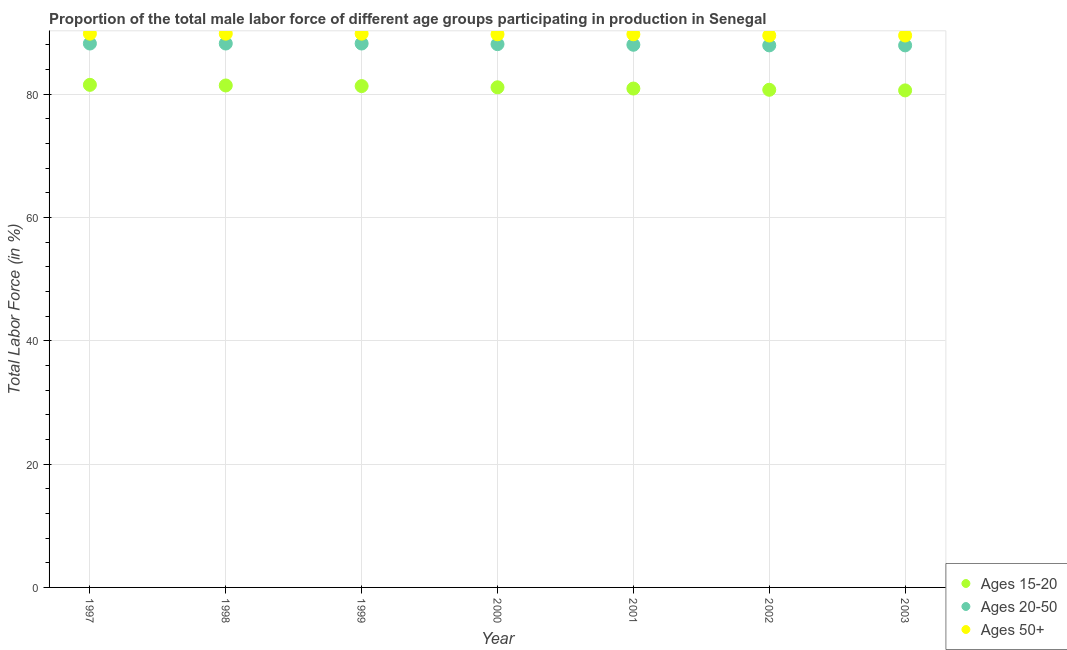How many different coloured dotlines are there?
Offer a terse response. 3. Is the number of dotlines equal to the number of legend labels?
Offer a terse response. Yes. What is the percentage of male labor force above age 50 in 2000?
Provide a succinct answer. 89.7. Across all years, what is the maximum percentage of male labor force above age 50?
Provide a short and direct response. 89.8. Across all years, what is the minimum percentage of male labor force within the age group 15-20?
Offer a very short reply. 80.6. In which year was the percentage of male labor force within the age group 20-50 maximum?
Provide a short and direct response. 1997. What is the total percentage of male labor force within the age group 15-20 in the graph?
Give a very brief answer. 567.5. What is the difference between the percentage of male labor force within the age group 20-50 in 2000 and that in 2001?
Offer a terse response. 0.1. What is the difference between the percentage of male labor force within the age group 15-20 in 2001 and the percentage of male labor force above age 50 in 1999?
Ensure brevity in your answer.  -8.9. What is the average percentage of male labor force above age 50 per year?
Provide a succinct answer. 89.69. In the year 1999, what is the difference between the percentage of male labor force within the age group 15-20 and percentage of male labor force within the age group 20-50?
Give a very brief answer. -6.9. What is the ratio of the percentage of male labor force within the age group 20-50 in 1997 to that in 2002?
Your answer should be compact. 1. Is the percentage of male labor force above age 50 in 1997 less than that in 1998?
Your answer should be very brief. No. What is the difference between the highest and the second highest percentage of male labor force above age 50?
Offer a very short reply. 0. What is the difference between the highest and the lowest percentage of male labor force within the age group 20-50?
Provide a short and direct response. 0.3. In how many years, is the percentage of male labor force above age 50 greater than the average percentage of male labor force above age 50 taken over all years?
Provide a succinct answer. 5. Is it the case that in every year, the sum of the percentage of male labor force within the age group 15-20 and percentage of male labor force within the age group 20-50 is greater than the percentage of male labor force above age 50?
Give a very brief answer. Yes. Does the percentage of male labor force within the age group 15-20 monotonically increase over the years?
Give a very brief answer. No. Is the percentage of male labor force within the age group 20-50 strictly less than the percentage of male labor force within the age group 15-20 over the years?
Make the answer very short. No. Does the graph contain grids?
Offer a terse response. Yes. How many legend labels are there?
Ensure brevity in your answer.  3. What is the title of the graph?
Offer a terse response. Proportion of the total male labor force of different age groups participating in production in Senegal. Does "Ages 15-64" appear as one of the legend labels in the graph?
Provide a short and direct response. No. What is the label or title of the X-axis?
Keep it short and to the point. Year. What is the label or title of the Y-axis?
Your answer should be very brief. Total Labor Force (in %). What is the Total Labor Force (in %) of Ages 15-20 in 1997?
Offer a very short reply. 81.5. What is the Total Labor Force (in %) of Ages 20-50 in 1997?
Provide a short and direct response. 88.2. What is the Total Labor Force (in %) of Ages 50+ in 1997?
Give a very brief answer. 89.8. What is the Total Labor Force (in %) of Ages 15-20 in 1998?
Make the answer very short. 81.4. What is the Total Labor Force (in %) of Ages 20-50 in 1998?
Your response must be concise. 88.2. What is the Total Labor Force (in %) of Ages 50+ in 1998?
Your answer should be very brief. 89.8. What is the Total Labor Force (in %) of Ages 15-20 in 1999?
Offer a very short reply. 81.3. What is the Total Labor Force (in %) of Ages 20-50 in 1999?
Offer a terse response. 88.2. What is the Total Labor Force (in %) of Ages 50+ in 1999?
Keep it short and to the point. 89.8. What is the Total Labor Force (in %) in Ages 15-20 in 2000?
Your answer should be compact. 81.1. What is the Total Labor Force (in %) in Ages 20-50 in 2000?
Offer a terse response. 88.1. What is the Total Labor Force (in %) of Ages 50+ in 2000?
Offer a very short reply. 89.7. What is the Total Labor Force (in %) of Ages 15-20 in 2001?
Your answer should be very brief. 80.9. What is the Total Labor Force (in %) in Ages 20-50 in 2001?
Provide a short and direct response. 88. What is the Total Labor Force (in %) of Ages 50+ in 2001?
Your answer should be compact. 89.7. What is the Total Labor Force (in %) of Ages 15-20 in 2002?
Make the answer very short. 80.7. What is the Total Labor Force (in %) in Ages 20-50 in 2002?
Offer a terse response. 87.9. What is the Total Labor Force (in %) in Ages 50+ in 2002?
Keep it short and to the point. 89.5. What is the Total Labor Force (in %) in Ages 15-20 in 2003?
Make the answer very short. 80.6. What is the Total Labor Force (in %) in Ages 20-50 in 2003?
Give a very brief answer. 87.9. What is the Total Labor Force (in %) in Ages 50+ in 2003?
Make the answer very short. 89.5. Across all years, what is the maximum Total Labor Force (in %) of Ages 15-20?
Offer a very short reply. 81.5. Across all years, what is the maximum Total Labor Force (in %) in Ages 20-50?
Your answer should be compact. 88.2. Across all years, what is the maximum Total Labor Force (in %) in Ages 50+?
Your answer should be compact. 89.8. Across all years, what is the minimum Total Labor Force (in %) of Ages 15-20?
Offer a very short reply. 80.6. Across all years, what is the minimum Total Labor Force (in %) in Ages 20-50?
Provide a succinct answer. 87.9. Across all years, what is the minimum Total Labor Force (in %) in Ages 50+?
Offer a very short reply. 89.5. What is the total Total Labor Force (in %) in Ages 15-20 in the graph?
Your response must be concise. 567.5. What is the total Total Labor Force (in %) of Ages 20-50 in the graph?
Provide a succinct answer. 616.5. What is the total Total Labor Force (in %) in Ages 50+ in the graph?
Your answer should be compact. 627.8. What is the difference between the Total Labor Force (in %) of Ages 20-50 in 1997 and that in 1998?
Give a very brief answer. 0. What is the difference between the Total Labor Force (in %) of Ages 15-20 in 1997 and that in 1999?
Ensure brevity in your answer.  0.2. What is the difference between the Total Labor Force (in %) in Ages 20-50 in 1997 and that in 1999?
Ensure brevity in your answer.  0. What is the difference between the Total Labor Force (in %) in Ages 50+ in 1997 and that in 1999?
Keep it short and to the point. 0. What is the difference between the Total Labor Force (in %) in Ages 20-50 in 1997 and that in 2000?
Give a very brief answer. 0.1. What is the difference between the Total Labor Force (in %) in Ages 50+ in 1997 and that in 2000?
Your answer should be very brief. 0.1. What is the difference between the Total Labor Force (in %) in Ages 15-20 in 1997 and that in 2001?
Your answer should be very brief. 0.6. What is the difference between the Total Labor Force (in %) in Ages 15-20 in 1997 and that in 2002?
Provide a succinct answer. 0.8. What is the difference between the Total Labor Force (in %) in Ages 20-50 in 1997 and that in 2002?
Provide a short and direct response. 0.3. What is the difference between the Total Labor Force (in %) of Ages 50+ in 1997 and that in 2003?
Offer a terse response. 0.3. What is the difference between the Total Labor Force (in %) in Ages 20-50 in 1998 and that in 1999?
Keep it short and to the point. 0. What is the difference between the Total Labor Force (in %) of Ages 15-20 in 1998 and that in 2000?
Keep it short and to the point. 0.3. What is the difference between the Total Labor Force (in %) of Ages 15-20 in 1998 and that in 2001?
Make the answer very short. 0.5. What is the difference between the Total Labor Force (in %) of Ages 20-50 in 1998 and that in 2001?
Give a very brief answer. 0.2. What is the difference between the Total Labor Force (in %) in Ages 50+ in 1998 and that in 2001?
Your answer should be very brief. 0.1. What is the difference between the Total Labor Force (in %) in Ages 50+ in 1998 and that in 2002?
Give a very brief answer. 0.3. What is the difference between the Total Labor Force (in %) of Ages 15-20 in 1998 and that in 2003?
Provide a short and direct response. 0.8. What is the difference between the Total Labor Force (in %) of Ages 50+ in 1998 and that in 2003?
Provide a succinct answer. 0.3. What is the difference between the Total Labor Force (in %) in Ages 50+ in 1999 and that in 2000?
Your response must be concise. 0.1. What is the difference between the Total Labor Force (in %) of Ages 15-20 in 1999 and that in 2001?
Provide a succinct answer. 0.4. What is the difference between the Total Labor Force (in %) of Ages 20-50 in 1999 and that in 2001?
Provide a succinct answer. 0.2. What is the difference between the Total Labor Force (in %) in Ages 15-20 in 1999 and that in 2002?
Ensure brevity in your answer.  0.6. What is the difference between the Total Labor Force (in %) in Ages 50+ in 1999 and that in 2002?
Make the answer very short. 0.3. What is the difference between the Total Labor Force (in %) of Ages 15-20 in 1999 and that in 2003?
Provide a short and direct response. 0.7. What is the difference between the Total Labor Force (in %) in Ages 50+ in 1999 and that in 2003?
Your response must be concise. 0.3. What is the difference between the Total Labor Force (in %) in Ages 20-50 in 2000 and that in 2001?
Your answer should be compact. 0.1. What is the difference between the Total Labor Force (in %) in Ages 20-50 in 2000 and that in 2002?
Provide a succinct answer. 0.2. What is the difference between the Total Labor Force (in %) of Ages 50+ in 2001 and that in 2002?
Offer a terse response. 0.2. What is the difference between the Total Labor Force (in %) in Ages 15-20 in 2001 and that in 2003?
Give a very brief answer. 0.3. What is the difference between the Total Labor Force (in %) of Ages 20-50 in 2002 and that in 2003?
Your answer should be compact. 0. What is the difference between the Total Labor Force (in %) of Ages 15-20 in 1997 and the Total Labor Force (in %) of Ages 20-50 in 1998?
Provide a short and direct response. -6.7. What is the difference between the Total Labor Force (in %) of Ages 15-20 in 1997 and the Total Labor Force (in %) of Ages 50+ in 1998?
Offer a very short reply. -8.3. What is the difference between the Total Labor Force (in %) of Ages 15-20 in 1997 and the Total Labor Force (in %) of Ages 20-50 in 1999?
Offer a very short reply. -6.7. What is the difference between the Total Labor Force (in %) in Ages 15-20 in 1997 and the Total Labor Force (in %) in Ages 50+ in 1999?
Make the answer very short. -8.3. What is the difference between the Total Labor Force (in %) in Ages 15-20 in 1997 and the Total Labor Force (in %) in Ages 20-50 in 2000?
Your answer should be compact. -6.6. What is the difference between the Total Labor Force (in %) of Ages 15-20 in 1997 and the Total Labor Force (in %) of Ages 20-50 in 2001?
Provide a succinct answer. -6.5. What is the difference between the Total Labor Force (in %) in Ages 20-50 in 1997 and the Total Labor Force (in %) in Ages 50+ in 2001?
Ensure brevity in your answer.  -1.5. What is the difference between the Total Labor Force (in %) of Ages 15-20 in 1997 and the Total Labor Force (in %) of Ages 20-50 in 2003?
Provide a short and direct response. -6.4. What is the difference between the Total Labor Force (in %) of Ages 15-20 in 1997 and the Total Labor Force (in %) of Ages 50+ in 2003?
Make the answer very short. -8. What is the difference between the Total Labor Force (in %) in Ages 15-20 in 1998 and the Total Labor Force (in %) in Ages 20-50 in 1999?
Offer a very short reply. -6.8. What is the difference between the Total Labor Force (in %) of Ages 20-50 in 1998 and the Total Labor Force (in %) of Ages 50+ in 2000?
Your response must be concise. -1.5. What is the difference between the Total Labor Force (in %) in Ages 15-20 in 1998 and the Total Labor Force (in %) in Ages 20-50 in 2001?
Keep it short and to the point. -6.6. What is the difference between the Total Labor Force (in %) in Ages 15-20 in 1998 and the Total Labor Force (in %) in Ages 20-50 in 2002?
Your answer should be compact. -6.5. What is the difference between the Total Labor Force (in %) of Ages 15-20 in 1998 and the Total Labor Force (in %) of Ages 50+ in 2002?
Keep it short and to the point. -8.1. What is the difference between the Total Labor Force (in %) in Ages 20-50 in 1998 and the Total Labor Force (in %) in Ages 50+ in 2002?
Ensure brevity in your answer.  -1.3. What is the difference between the Total Labor Force (in %) in Ages 15-20 in 1998 and the Total Labor Force (in %) in Ages 50+ in 2003?
Make the answer very short. -8.1. What is the difference between the Total Labor Force (in %) in Ages 20-50 in 1998 and the Total Labor Force (in %) in Ages 50+ in 2003?
Ensure brevity in your answer.  -1.3. What is the difference between the Total Labor Force (in %) of Ages 15-20 in 1999 and the Total Labor Force (in %) of Ages 20-50 in 2000?
Your answer should be compact. -6.8. What is the difference between the Total Labor Force (in %) of Ages 15-20 in 1999 and the Total Labor Force (in %) of Ages 50+ in 2000?
Your response must be concise. -8.4. What is the difference between the Total Labor Force (in %) of Ages 15-20 in 1999 and the Total Labor Force (in %) of Ages 50+ in 2001?
Make the answer very short. -8.4. What is the difference between the Total Labor Force (in %) in Ages 15-20 in 1999 and the Total Labor Force (in %) in Ages 20-50 in 2002?
Provide a short and direct response. -6.6. What is the difference between the Total Labor Force (in %) of Ages 15-20 in 1999 and the Total Labor Force (in %) of Ages 20-50 in 2003?
Keep it short and to the point. -6.6. What is the difference between the Total Labor Force (in %) of Ages 15-20 in 1999 and the Total Labor Force (in %) of Ages 50+ in 2003?
Ensure brevity in your answer.  -8.2. What is the difference between the Total Labor Force (in %) in Ages 20-50 in 1999 and the Total Labor Force (in %) in Ages 50+ in 2003?
Your answer should be very brief. -1.3. What is the difference between the Total Labor Force (in %) of Ages 15-20 in 2000 and the Total Labor Force (in %) of Ages 20-50 in 2001?
Offer a terse response. -6.9. What is the difference between the Total Labor Force (in %) in Ages 15-20 in 2000 and the Total Labor Force (in %) in Ages 50+ in 2001?
Ensure brevity in your answer.  -8.6. What is the difference between the Total Labor Force (in %) in Ages 20-50 in 2000 and the Total Labor Force (in %) in Ages 50+ in 2001?
Make the answer very short. -1.6. What is the difference between the Total Labor Force (in %) of Ages 15-20 in 2000 and the Total Labor Force (in %) of Ages 20-50 in 2002?
Offer a very short reply. -6.8. What is the difference between the Total Labor Force (in %) of Ages 15-20 in 2000 and the Total Labor Force (in %) of Ages 50+ in 2003?
Offer a very short reply. -8.4. What is the difference between the Total Labor Force (in %) of Ages 15-20 in 2001 and the Total Labor Force (in %) of Ages 50+ in 2002?
Your answer should be very brief. -8.6. What is the difference between the Total Labor Force (in %) of Ages 15-20 in 2001 and the Total Labor Force (in %) of Ages 20-50 in 2003?
Your response must be concise. -7. What is the difference between the Total Labor Force (in %) in Ages 15-20 in 2001 and the Total Labor Force (in %) in Ages 50+ in 2003?
Your answer should be very brief. -8.6. What is the difference between the Total Labor Force (in %) of Ages 15-20 in 2002 and the Total Labor Force (in %) of Ages 20-50 in 2003?
Ensure brevity in your answer.  -7.2. What is the difference between the Total Labor Force (in %) of Ages 15-20 in 2002 and the Total Labor Force (in %) of Ages 50+ in 2003?
Give a very brief answer. -8.8. What is the difference between the Total Labor Force (in %) in Ages 20-50 in 2002 and the Total Labor Force (in %) in Ages 50+ in 2003?
Give a very brief answer. -1.6. What is the average Total Labor Force (in %) of Ages 15-20 per year?
Provide a short and direct response. 81.07. What is the average Total Labor Force (in %) of Ages 20-50 per year?
Offer a very short reply. 88.07. What is the average Total Labor Force (in %) in Ages 50+ per year?
Provide a succinct answer. 89.69. In the year 1997, what is the difference between the Total Labor Force (in %) in Ages 15-20 and Total Labor Force (in %) in Ages 50+?
Offer a very short reply. -8.3. In the year 1997, what is the difference between the Total Labor Force (in %) of Ages 20-50 and Total Labor Force (in %) of Ages 50+?
Give a very brief answer. -1.6. In the year 1998, what is the difference between the Total Labor Force (in %) of Ages 15-20 and Total Labor Force (in %) of Ages 20-50?
Offer a terse response. -6.8. In the year 1998, what is the difference between the Total Labor Force (in %) of Ages 15-20 and Total Labor Force (in %) of Ages 50+?
Ensure brevity in your answer.  -8.4. In the year 1999, what is the difference between the Total Labor Force (in %) of Ages 15-20 and Total Labor Force (in %) of Ages 20-50?
Your response must be concise. -6.9. In the year 1999, what is the difference between the Total Labor Force (in %) of Ages 20-50 and Total Labor Force (in %) of Ages 50+?
Keep it short and to the point. -1.6. In the year 2000, what is the difference between the Total Labor Force (in %) in Ages 15-20 and Total Labor Force (in %) in Ages 50+?
Your answer should be very brief. -8.6. In the year 2000, what is the difference between the Total Labor Force (in %) in Ages 20-50 and Total Labor Force (in %) in Ages 50+?
Your answer should be compact. -1.6. In the year 2001, what is the difference between the Total Labor Force (in %) of Ages 15-20 and Total Labor Force (in %) of Ages 20-50?
Your answer should be compact. -7.1. In the year 2001, what is the difference between the Total Labor Force (in %) in Ages 15-20 and Total Labor Force (in %) in Ages 50+?
Provide a succinct answer. -8.8. In the year 2002, what is the difference between the Total Labor Force (in %) of Ages 15-20 and Total Labor Force (in %) of Ages 20-50?
Ensure brevity in your answer.  -7.2. In the year 2002, what is the difference between the Total Labor Force (in %) of Ages 15-20 and Total Labor Force (in %) of Ages 50+?
Offer a terse response. -8.8. In the year 2003, what is the difference between the Total Labor Force (in %) of Ages 15-20 and Total Labor Force (in %) of Ages 20-50?
Ensure brevity in your answer.  -7.3. In the year 2003, what is the difference between the Total Labor Force (in %) in Ages 15-20 and Total Labor Force (in %) in Ages 50+?
Ensure brevity in your answer.  -8.9. In the year 2003, what is the difference between the Total Labor Force (in %) in Ages 20-50 and Total Labor Force (in %) in Ages 50+?
Provide a succinct answer. -1.6. What is the ratio of the Total Labor Force (in %) in Ages 15-20 in 1997 to that in 1998?
Your response must be concise. 1. What is the ratio of the Total Labor Force (in %) of Ages 50+ in 1997 to that in 1998?
Make the answer very short. 1. What is the ratio of the Total Labor Force (in %) in Ages 15-20 in 1997 to that in 1999?
Ensure brevity in your answer.  1. What is the ratio of the Total Labor Force (in %) in Ages 20-50 in 1997 to that in 1999?
Give a very brief answer. 1. What is the ratio of the Total Labor Force (in %) in Ages 20-50 in 1997 to that in 2000?
Offer a very short reply. 1. What is the ratio of the Total Labor Force (in %) in Ages 15-20 in 1997 to that in 2001?
Offer a very short reply. 1.01. What is the ratio of the Total Labor Force (in %) in Ages 15-20 in 1997 to that in 2002?
Provide a short and direct response. 1.01. What is the ratio of the Total Labor Force (in %) of Ages 15-20 in 1997 to that in 2003?
Your answer should be compact. 1.01. What is the ratio of the Total Labor Force (in %) in Ages 20-50 in 1997 to that in 2003?
Make the answer very short. 1. What is the ratio of the Total Labor Force (in %) of Ages 50+ in 1997 to that in 2003?
Your answer should be compact. 1. What is the ratio of the Total Labor Force (in %) in Ages 20-50 in 1998 to that in 1999?
Your answer should be compact. 1. What is the ratio of the Total Labor Force (in %) in Ages 15-20 in 1998 to that in 2000?
Make the answer very short. 1. What is the ratio of the Total Labor Force (in %) of Ages 50+ in 1998 to that in 2000?
Your response must be concise. 1. What is the ratio of the Total Labor Force (in %) of Ages 15-20 in 1998 to that in 2002?
Offer a very short reply. 1.01. What is the ratio of the Total Labor Force (in %) of Ages 20-50 in 1998 to that in 2002?
Give a very brief answer. 1. What is the ratio of the Total Labor Force (in %) in Ages 15-20 in 1998 to that in 2003?
Your answer should be compact. 1.01. What is the ratio of the Total Labor Force (in %) in Ages 20-50 in 1998 to that in 2003?
Provide a succinct answer. 1. What is the ratio of the Total Labor Force (in %) in Ages 50+ in 1998 to that in 2003?
Provide a short and direct response. 1. What is the ratio of the Total Labor Force (in %) of Ages 20-50 in 1999 to that in 2001?
Provide a short and direct response. 1. What is the ratio of the Total Labor Force (in %) of Ages 15-20 in 1999 to that in 2002?
Offer a very short reply. 1.01. What is the ratio of the Total Labor Force (in %) of Ages 20-50 in 1999 to that in 2002?
Your response must be concise. 1. What is the ratio of the Total Labor Force (in %) in Ages 15-20 in 1999 to that in 2003?
Provide a short and direct response. 1.01. What is the ratio of the Total Labor Force (in %) in Ages 50+ in 1999 to that in 2003?
Provide a short and direct response. 1. What is the ratio of the Total Labor Force (in %) of Ages 20-50 in 2000 to that in 2001?
Offer a terse response. 1. What is the ratio of the Total Labor Force (in %) of Ages 50+ in 2000 to that in 2001?
Provide a short and direct response. 1. What is the ratio of the Total Labor Force (in %) in Ages 20-50 in 2000 to that in 2002?
Provide a succinct answer. 1. What is the ratio of the Total Labor Force (in %) of Ages 15-20 in 2000 to that in 2003?
Provide a succinct answer. 1.01. What is the ratio of the Total Labor Force (in %) of Ages 50+ in 2000 to that in 2003?
Your answer should be compact. 1. What is the ratio of the Total Labor Force (in %) in Ages 50+ in 2001 to that in 2002?
Offer a terse response. 1. What is the ratio of the Total Labor Force (in %) of Ages 15-20 in 2001 to that in 2003?
Give a very brief answer. 1. What is the ratio of the Total Labor Force (in %) in Ages 50+ in 2001 to that in 2003?
Offer a very short reply. 1. What is the difference between the highest and the lowest Total Labor Force (in %) in Ages 50+?
Keep it short and to the point. 0.3. 